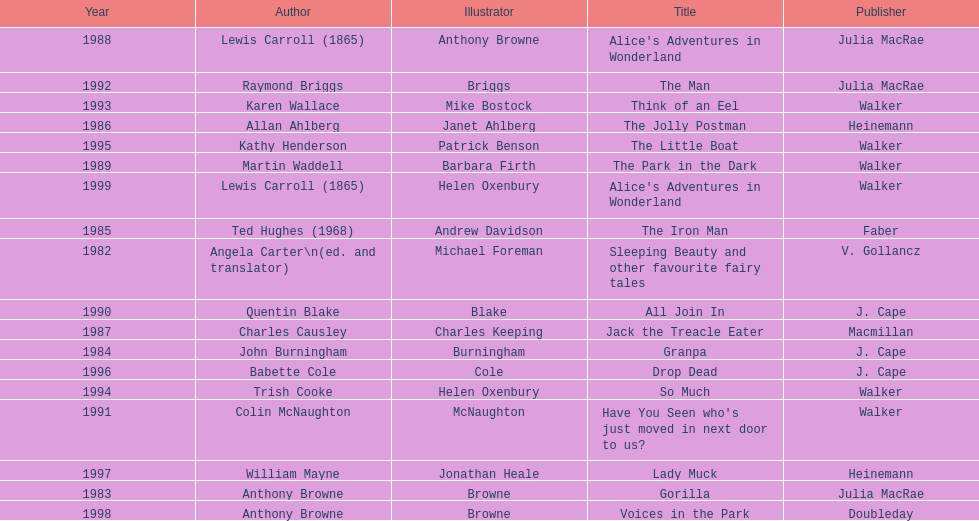How many complete titles has walker published? 5. 